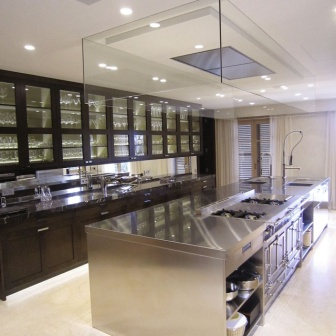Analyze the image in a comprehensive and detailed manner. The image showcases a luxurious kitchen designed for both aesthetic appeal and functionality. It features a large central island made of lustrous stainless steel, equipped with a gas range and a modern faucet over the sink, ideal for preparing meals and entertaining guests. The island serves as the focal point, surrounded by plush dark wood cabinetry. These cabinets, with their glass doors, not only provide storage but also allow one to display fine glassware and china, adding a decorative touch to the space. The expansive window, covered by minimalist white blinds, floods the kitchen with natural light, enhancing the gleam of the polished steel and creating an inviting ambiance. Above, a contemporary glass pendant light echoes the kitchen’s modern theme, providing excellent task lighting. The tile flooring in a subtle cream shade complements the overall neutral color palette, making the kitchen seem larger and even more open. This kitchen efficiently merges style with practicality, providing a clear insight into modern kitchen design trends focused on creating a social and functional space. 